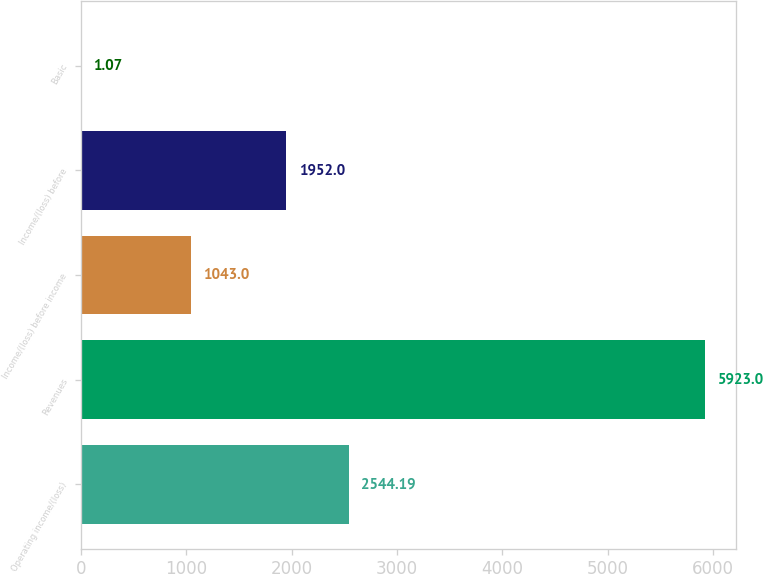<chart> <loc_0><loc_0><loc_500><loc_500><bar_chart><fcel>Operating income/(loss)<fcel>Revenues<fcel>Income/(loss) before income<fcel>Income/(loss) before<fcel>Basic<nl><fcel>2544.19<fcel>5923<fcel>1043<fcel>1952<fcel>1.07<nl></chart> 